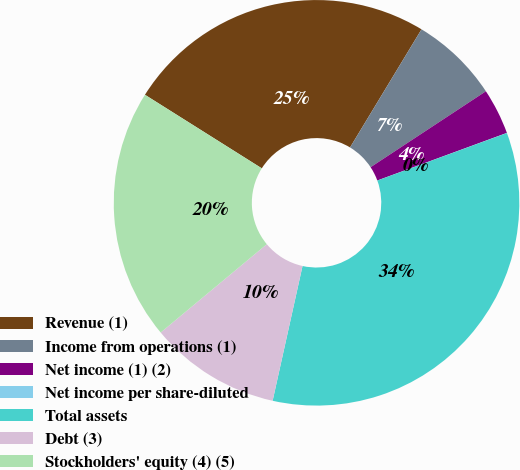Convert chart to OTSL. <chart><loc_0><loc_0><loc_500><loc_500><pie_chart><fcel>Revenue (1)<fcel>Income from operations (1)<fcel>Net income (1) (2)<fcel>Net income per share-diluted<fcel>Total assets<fcel>Debt (3)<fcel>Stockholders' equity (4) (5)<nl><fcel>24.72%<fcel>7.07%<fcel>3.67%<fcel>0.01%<fcel>34.07%<fcel>10.48%<fcel>19.99%<nl></chart> 